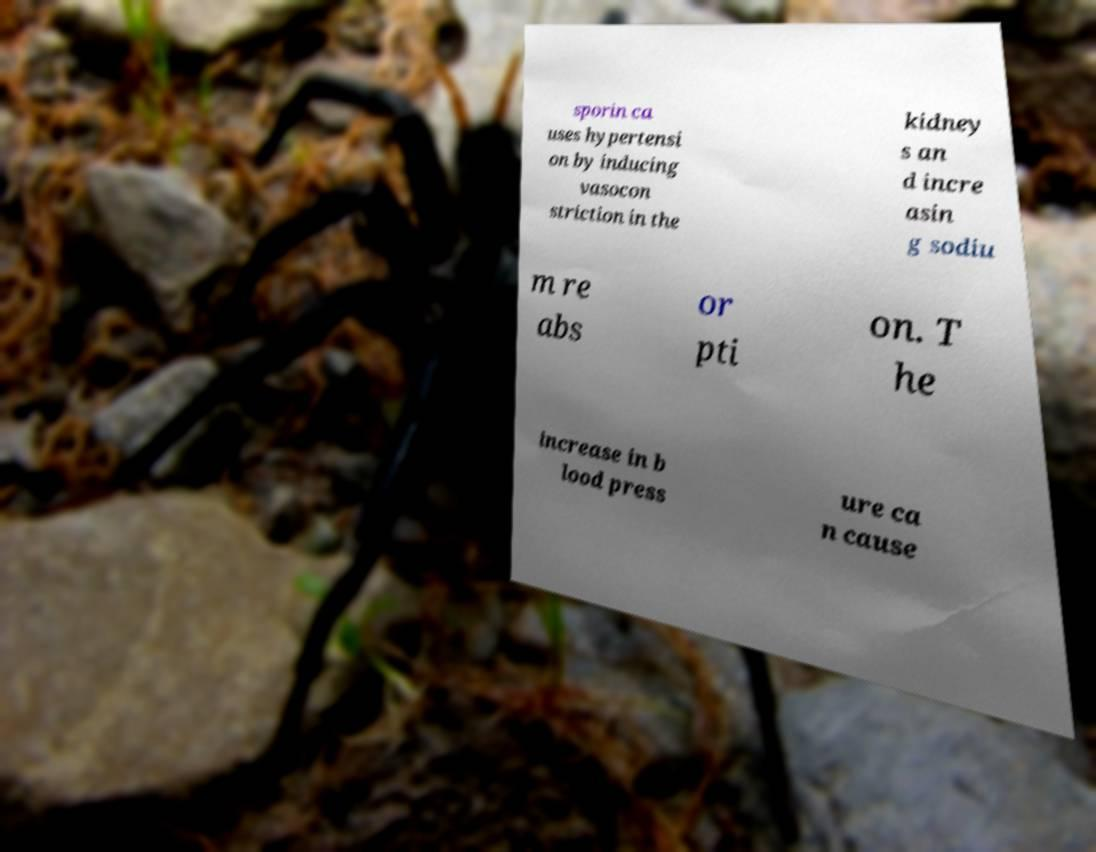Please read and relay the text visible in this image. What does it say? sporin ca uses hypertensi on by inducing vasocon striction in the kidney s an d incre asin g sodiu m re abs or pti on. T he increase in b lood press ure ca n cause 